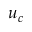Convert formula to latex. <formula><loc_0><loc_0><loc_500><loc_500>u _ { c }</formula> 